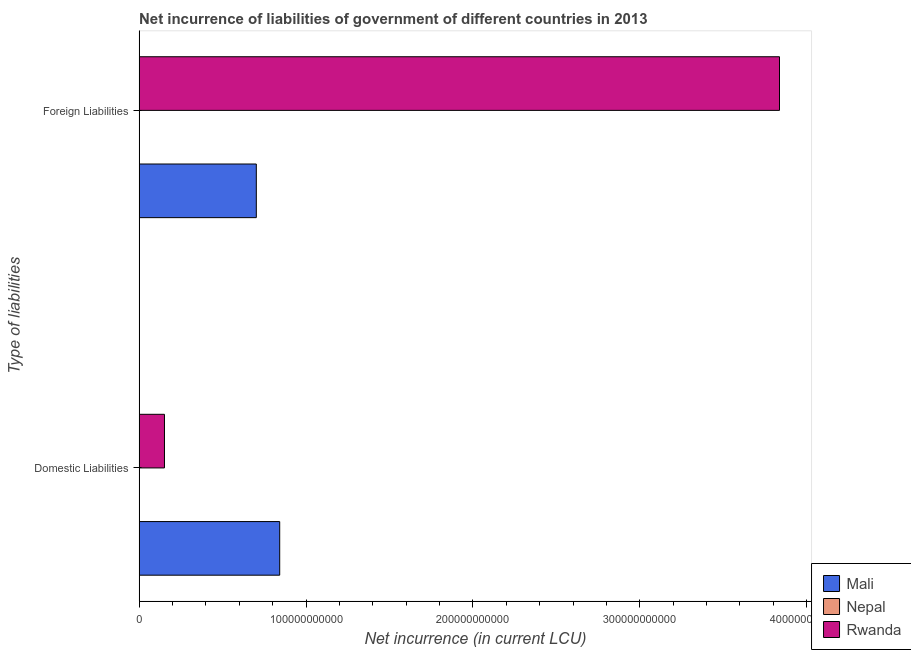How many different coloured bars are there?
Your response must be concise. 2. How many groups of bars are there?
Your response must be concise. 2. Are the number of bars per tick equal to the number of legend labels?
Keep it short and to the point. No. What is the label of the 1st group of bars from the top?
Your answer should be compact. Foreign Liabilities. What is the net incurrence of domestic liabilities in Mali?
Your answer should be compact. 8.42e+1. Across all countries, what is the maximum net incurrence of domestic liabilities?
Offer a terse response. 8.42e+1. In which country was the net incurrence of foreign liabilities maximum?
Provide a short and direct response. Rwanda. What is the total net incurrence of domestic liabilities in the graph?
Offer a terse response. 9.94e+1. What is the difference between the net incurrence of foreign liabilities in Mali and that in Rwanda?
Ensure brevity in your answer.  -3.13e+11. What is the difference between the net incurrence of domestic liabilities in Rwanda and the net incurrence of foreign liabilities in Nepal?
Your answer should be compact. 1.52e+1. What is the average net incurrence of foreign liabilities per country?
Keep it short and to the point. 1.51e+11. What is the difference between the net incurrence of foreign liabilities and net incurrence of domestic liabilities in Rwanda?
Provide a succinct answer. 3.68e+11. In how many countries, is the net incurrence of domestic liabilities greater than 200000000000 LCU?
Provide a succinct answer. 0. What is the ratio of the net incurrence of domestic liabilities in Rwanda to that in Mali?
Offer a terse response. 0.18. How many countries are there in the graph?
Make the answer very short. 3. What is the difference between two consecutive major ticks on the X-axis?
Give a very brief answer. 1.00e+11. Are the values on the major ticks of X-axis written in scientific E-notation?
Offer a terse response. No. Does the graph contain any zero values?
Your response must be concise. Yes. Does the graph contain grids?
Ensure brevity in your answer.  No. What is the title of the graph?
Provide a succinct answer. Net incurrence of liabilities of government of different countries in 2013. Does "Yemen, Rep." appear as one of the legend labels in the graph?
Give a very brief answer. No. What is the label or title of the X-axis?
Provide a succinct answer. Net incurrence (in current LCU). What is the label or title of the Y-axis?
Provide a short and direct response. Type of liabilities. What is the Net incurrence (in current LCU) in Mali in Domestic Liabilities?
Give a very brief answer. 8.42e+1. What is the Net incurrence (in current LCU) in Rwanda in Domestic Liabilities?
Make the answer very short. 1.52e+1. What is the Net incurrence (in current LCU) of Mali in Foreign Liabilities?
Offer a very short reply. 7.02e+1. What is the Net incurrence (in current LCU) of Rwanda in Foreign Liabilities?
Your response must be concise. 3.84e+11. Across all Type of liabilities, what is the maximum Net incurrence (in current LCU) of Mali?
Offer a very short reply. 8.42e+1. Across all Type of liabilities, what is the maximum Net incurrence (in current LCU) of Rwanda?
Ensure brevity in your answer.  3.84e+11. Across all Type of liabilities, what is the minimum Net incurrence (in current LCU) of Mali?
Ensure brevity in your answer.  7.02e+1. Across all Type of liabilities, what is the minimum Net incurrence (in current LCU) of Rwanda?
Offer a very short reply. 1.52e+1. What is the total Net incurrence (in current LCU) in Mali in the graph?
Ensure brevity in your answer.  1.54e+11. What is the total Net incurrence (in current LCU) in Nepal in the graph?
Your response must be concise. 0. What is the total Net incurrence (in current LCU) in Rwanda in the graph?
Your answer should be very brief. 3.99e+11. What is the difference between the Net incurrence (in current LCU) of Mali in Domestic Liabilities and that in Foreign Liabilities?
Your answer should be compact. 1.40e+1. What is the difference between the Net incurrence (in current LCU) of Rwanda in Domestic Liabilities and that in Foreign Liabilities?
Provide a succinct answer. -3.68e+11. What is the difference between the Net incurrence (in current LCU) in Mali in Domestic Liabilities and the Net incurrence (in current LCU) in Rwanda in Foreign Liabilities?
Your response must be concise. -2.99e+11. What is the average Net incurrence (in current LCU) of Mali per Type of liabilities?
Offer a very short reply. 7.72e+1. What is the average Net incurrence (in current LCU) in Rwanda per Type of liabilities?
Provide a succinct answer. 1.99e+11. What is the difference between the Net incurrence (in current LCU) in Mali and Net incurrence (in current LCU) in Rwanda in Domestic Liabilities?
Ensure brevity in your answer.  6.90e+1. What is the difference between the Net incurrence (in current LCU) of Mali and Net incurrence (in current LCU) of Rwanda in Foreign Liabilities?
Your response must be concise. -3.13e+11. What is the ratio of the Net incurrence (in current LCU) in Mali in Domestic Liabilities to that in Foreign Liabilities?
Provide a short and direct response. 1.2. What is the ratio of the Net incurrence (in current LCU) of Rwanda in Domestic Liabilities to that in Foreign Liabilities?
Make the answer very short. 0.04. What is the difference between the highest and the second highest Net incurrence (in current LCU) in Mali?
Offer a very short reply. 1.40e+1. What is the difference between the highest and the second highest Net incurrence (in current LCU) of Rwanda?
Provide a short and direct response. 3.68e+11. What is the difference between the highest and the lowest Net incurrence (in current LCU) of Mali?
Keep it short and to the point. 1.40e+1. What is the difference between the highest and the lowest Net incurrence (in current LCU) in Rwanda?
Ensure brevity in your answer.  3.68e+11. 